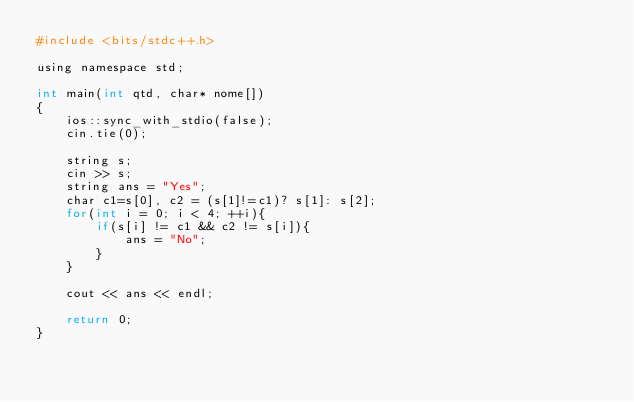<code> <loc_0><loc_0><loc_500><loc_500><_Awk_>#include <bits/stdc++.h>

using namespace std;

int main(int qtd, char* nome[])
{
    ios::sync_with_stdio(false);
    cin.tie(0);

    string s;
    cin >> s;
    string ans = "Yes";
    char c1=s[0], c2 = (s[1]!=c1)? s[1]: s[2];
    for(int i = 0; i < 4; ++i){
        if(s[i] != c1 && c2 != s[i]){
            ans = "No";
        }
    }

    cout << ans << endl;

    return 0;
}
</code> 